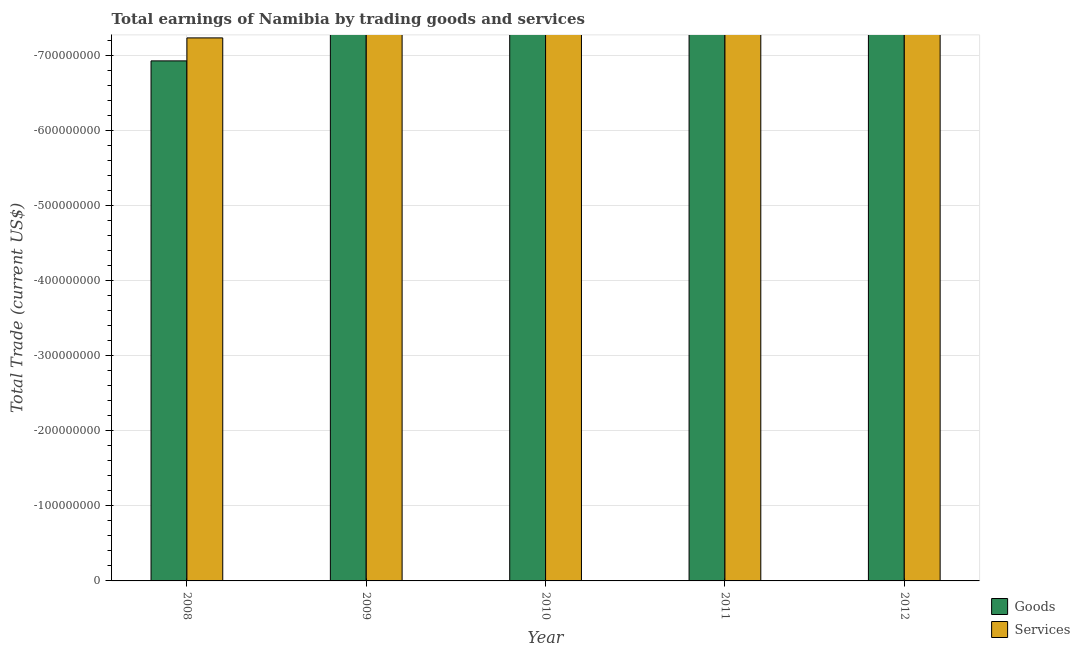How many different coloured bars are there?
Ensure brevity in your answer.  0. Are the number of bars per tick equal to the number of legend labels?
Ensure brevity in your answer.  No. Are the number of bars on each tick of the X-axis equal?
Give a very brief answer. Yes. How many bars are there on the 5th tick from the left?
Your answer should be very brief. 0. How many bars are there on the 1st tick from the right?
Give a very brief answer. 0. What is the label of the 4th group of bars from the left?
Your answer should be very brief. 2011. In how many cases, is the number of bars for a given year not equal to the number of legend labels?
Provide a succinct answer. 5. What is the total amount earned by trading services in the graph?
Your answer should be compact. 0. What is the average amount earned by trading services per year?
Make the answer very short. 0. How many bars are there?
Offer a very short reply. 0. Are all the bars in the graph horizontal?
Your response must be concise. No. How many years are there in the graph?
Provide a succinct answer. 5. How many legend labels are there?
Provide a short and direct response. 2. What is the title of the graph?
Ensure brevity in your answer.  Total earnings of Namibia by trading goods and services. What is the label or title of the Y-axis?
Make the answer very short. Total Trade (current US$). What is the Total Trade (current US$) in Goods in 2009?
Offer a very short reply. 0. What is the Total Trade (current US$) in Goods in 2010?
Your answer should be very brief. 0. What is the Total Trade (current US$) of Services in 2010?
Ensure brevity in your answer.  0. What is the Total Trade (current US$) in Services in 2011?
Your answer should be compact. 0. What is the Total Trade (current US$) in Goods in 2012?
Offer a very short reply. 0. What is the total Total Trade (current US$) in Services in the graph?
Provide a short and direct response. 0. What is the average Total Trade (current US$) in Goods per year?
Offer a terse response. 0. 